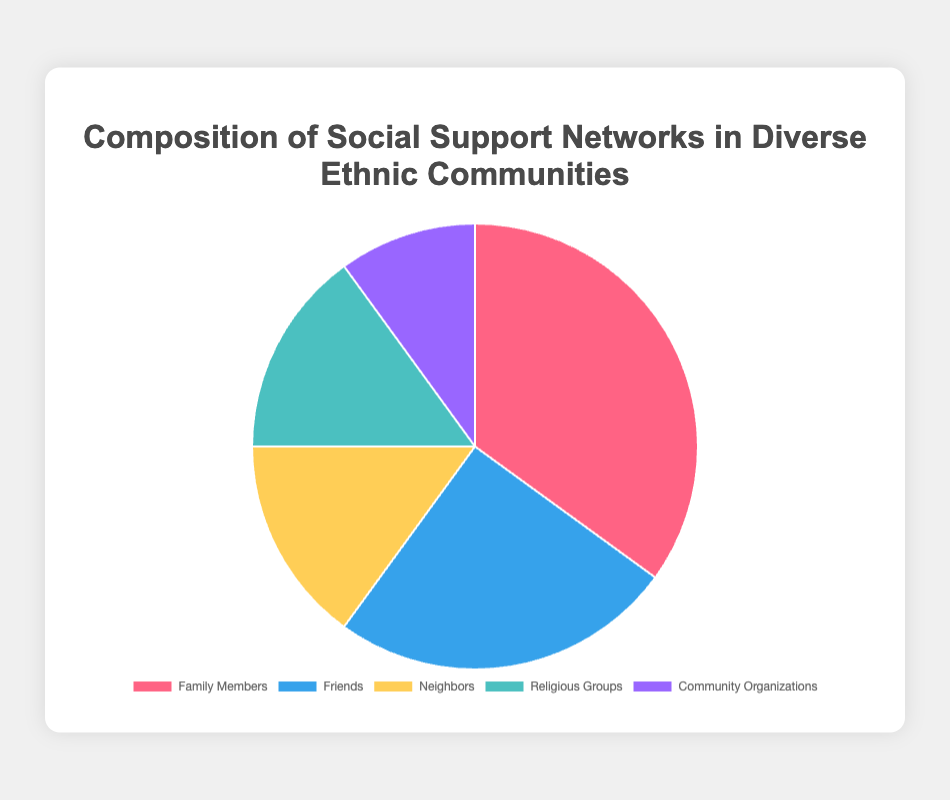What's the most prominent category of social support in diverse ethnic communities? The category with the highest percentage in the pie chart represents the most prominent source of social support. From the data, the category "Family Members" has the highest percentage of 35%.
Answer: Family Members Which category has the least representation in social support networks? The category with the lowest percentage in the pie chart represents the least prominent source of social support. From the data, "Community Organizations" has the lowest percentage of 10%.
Answer: Community Organizations How much more significant is the "Family Members" category compared to the "Neighbors" category in social support networks? To determine how much more significant one category is compared to another, subtract the smaller percentage from the larger percentage. Here, 35% (Family Members) - 15% (Neighbors) = 20%.
Answer: 20% What is the combined percentage of "Neighbors" and "Religious Groups"? To find the combined percentage, simply add the percentages of the two categories together. From the data, Neighbors is 15% and Religious Groups is 15%. So, 15% + 15% = 30%.
Answer: 30% Which two categories together contribute half of the social support in diverse ethnic communities? We need to find two categories whose combined percentages add up to 50%. Based on the given data, "Family Members" (35%) and "Friends" (25%) do not fit as they add up to more than 50%. The next highest combinations should be explored, and "Friends" (25%) and "Neighbors" (15%) combine for 40%, which is not enough. However, "Neighbors" (15%) and "Religious Groups" (15%) combine to 30%. Given this, "Family Members" (35%) combined with any small one like "Community Organizations" (10%) will also not work. However, it shows possible ones, and (15% + 15%) means only fits groups both in 30%:
Answer: Neighbors and Religious Groups What would be the impact on the overall chart if the percentage of "Community Organizations" were increased by 10%? Increasing the percentage of "Community Organizations" by 10% would change its value from 10% to 20%. The overall total percentage must always equal 100%. Therefore, increasing "Community Organizations" by 10% means decreasing other categories proportionally to maintain the total 100%. Simplifying the answer, one can state increases rather than detail higher level calculations.
Answer: Community Organizations increases by 10% Which category has the same visual attribute (color) as the second largest data point in the chart? The second largest data point is "Friends" at 25%. Looking at the chart and noting the color assigned, it appears visually distinct with a specific blue color.
Answer: Blue for Friends What are the three largest sources of social support in diverse ethnic communities? To determine the three largest sources of social support, we order categories by their percentages from highest to lowest: Family Members (35%), Friends (25%), and Neighbors (15%).
Answer: Family Members, Friends, and Neighbors How does the social support percentage from "Religious Groups" compare to that from "Community Organizations"? To compare the social support percentage, we directly look at the values. "Religious Groups" has a value of 15%, while "Community Organizations" has 10%. "Religious Groups" is therefore greater.
Answer: Religious Groups are greater than Community Organizations What is the total percentage represented by categories other than "Friends"? To find this, we subtract the percentage of "Friends" from 100%. 100% - 25% = 75%. So, the categories other than Friends sum up to 75%.
Answer: 75% 